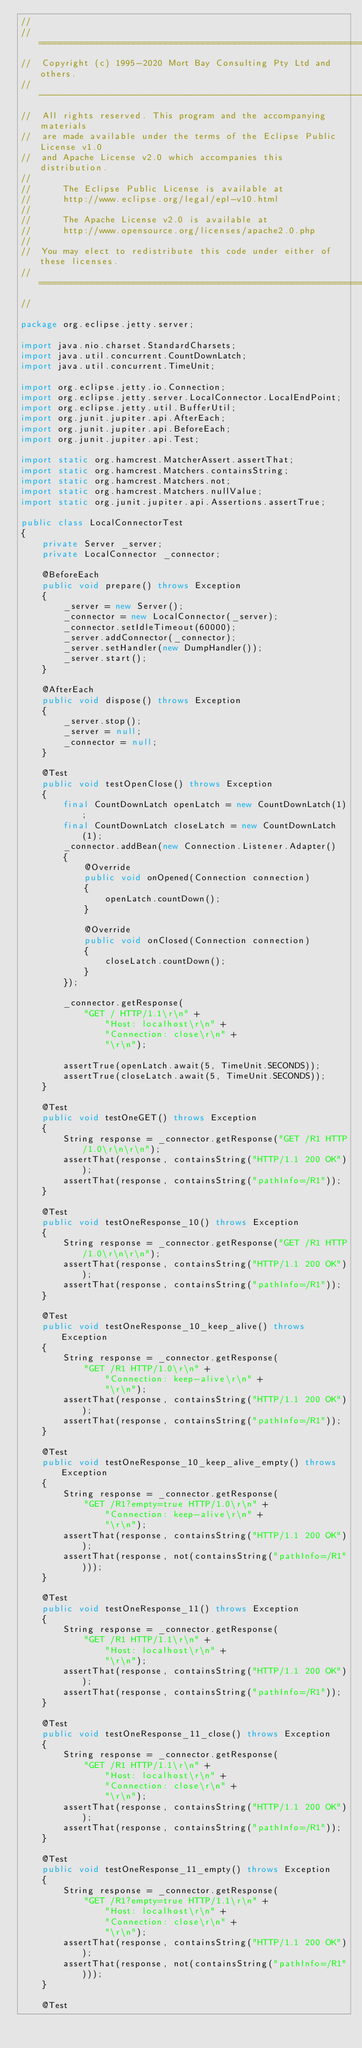<code> <loc_0><loc_0><loc_500><loc_500><_Java_>//
//  ========================================================================
//  Copyright (c) 1995-2020 Mort Bay Consulting Pty Ltd and others.
//  ------------------------------------------------------------------------
//  All rights reserved. This program and the accompanying materials
//  are made available under the terms of the Eclipse Public License v1.0
//  and Apache License v2.0 which accompanies this distribution.
//
//      The Eclipse Public License is available at
//      http://www.eclipse.org/legal/epl-v10.html
//
//      The Apache License v2.0 is available at
//      http://www.opensource.org/licenses/apache2.0.php
//
//  You may elect to redistribute this code under either of these licenses.
//  ========================================================================
//

package org.eclipse.jetty.server;

import java.nio.charset.StandardCharsets;
import java.util.concurrent.CountDownLatch;
import java.util.concurrent.TimeUnit;

import org.eclipse.jetty.io.Connection;
import org.eclipse.jetty.server.LocalConnector.LocalEndPoint;
import org.eclipse.jetty.util.BufferUtil;
import org.junit.jupiter.api.AfterEach;
import org.junit.jupiter.api.BeforeEach;
import org.junit.jupiter.api.Test;

import static org.hamcrest.MatcherAssert.assertThat;
import static org.hamcrest.Matchers.containsString;
import static org.hamcrest.Matchers.not;
import static org.hamcrest.Matchers.nullValue;
import static org.junit.jupiter.api.Assertions.assertTrue;

public class LocalConnectorTest
{
    private Server _server;
    private LocalConnector _connector;

    @BeforeEach
    public void prepare() throws Exception
    {
        _server = new Server();
        _connector = new LocalConnector(_server);
        _connector.setIdleTimeout(60000);
        _server.addConnector(_connector);
        _server.setHandler(new DumpHandler());
        _server.start();
    }

    @AfterEach
    public void dispose() throws Exception
    {
        _server.stop();
        _server = null;
        _connector = null;
    }

    @Test
    public void testOpenClose() throws Exception
    {
        final CountDownLatch openLatch = new CountDownLatch(1);
        final CountDownLatch closeLatch = new CountDownLatch(1);
        _connector.addBean(new Connection.Listener.Adapter()
        {
            @Override
            public void onOpened(Connection connection)
            {
                openLatch.countDown();
            }

            @Override
            public void onClosed(Connection connection)
            {
                closeLatch.countDown();
            }
        });

        _connector.getResponse(
            "GET / HTTP/1.1\r\n" +
                "Host: localhost\r\n" +
                "Connection: close\r\n" +
                "\r\n");

        assertTrue(openLatch.await(5, TimeUnit.SECONDS));
        assertTrue(closeLatch.await(5, TimeUnit.SECONDS));
    }

    @Test
    public void testOneGET() throws Exception
    {
        String response = _connector.getResponse("GET /R1 HTTP/1.0\r\n\r\n");
        assertThat(response, containsString("HTTP/1.1 200 OK"));
        assertThat(response, containsString("pathInfo=/R1"));
    }

    @Test
    public void testOneResponse_10() throws Exception
    {
        String response = _connector.getResponse("GET /R1 HTTP/1.0\r\n\r\n");
        assertThat(response, containsString("HTTP/1.1 200 OK"));
        assertThat(response, containsString("pathInfo=/R1"));
    }

    @Test
    public void testOneResponse_10_keep_alive() throws Exception
    {
        String response = _connector.getResponse(
            "GET /R1 HTTP/1.0\r\n" +
                "Connection: keep-alive\r\n" +
                "\r\n");
        assertThat(response, containsString("HTTP/1.1 200 OK"));
        assertThat(response, containsString("pathInfo=/R1"));
    }

    @Test
    public void testOneResponse_10_keep_alive_empty() throws Exception
    {
        String response = _connector.getResponse(
            "GET /R1?empty=true HTTP/1.0\r\n" +
                "Connection: keep-alive\r\n" +
                "\r\n");
        assertThat(response, containsString("HTTP/1.1 200 OK"));
        assertThat(response, not(containsString("pathInfo=/R1")));
    }

    @Test
    public void testOneResponse_11() throws Exception
    {
        String response = _connector.getResponse(
            "GET /R1 HTTP/1.1\r\n" +
                "Host: localhost\r\n" +
                "\r\n");
        assertThat(response, containsString("HTTP/1.1 200 OK"));
        assertThat(response, containsString("pathInfo=/R1"));
    }

    @Test
    public void testOneResponse_11_close() throws Exception
    {
        String response = _connector.getResponse(
            "GET /R1 HTTP/1.1\r\n" +
                "Host: localhost\r\n" +
                "Connection: close\r\n" +
                "\r\n");
        assertThat(response, containsString("HTTP/1.1 200 OK"));
        assertThat(response, containsString("pathInfo=/R1"));
    }

    @Test
    public void testOneResponse_11_empty() throws Exception
    {
        String response = _connector.getResponse(
            "GET /R1?empty=true HTTP/1.1\r\n" +
                "Host: localhost\r\n" +
                "Connection: close\r\n" +
                "\r\n");
        assertThat(response, containsString("HTTP/1.1 200 OK"));
        assertThat(response, not(containsString("pathInfo=/R1")));
    }

    @Test</code> 